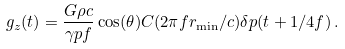Convert formula to latex. <formula><loc_0><loc_0><loc_500><loc_500>g _ { z } ( t ) = \frac { G \rho c } { \gamma p f } \cos ( \theta ) C ( 2 \pi f r _ { \min } / c ) \delta p ( t + 1 / 4 f ) \, .</formula> 